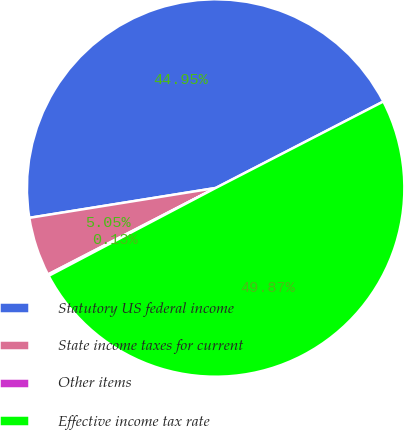<chart> <loc_0><loc_0><loc_500><loc_500><pie_chart><fcel>Statutory US federal income<fcel>State income taxes for current<fcel>Other items<fcel>Effective income tax rate<nl><fcel>44.95%<fcel>5.05%<fcel>0.13%<fcel>49.87%<nl></chart> 